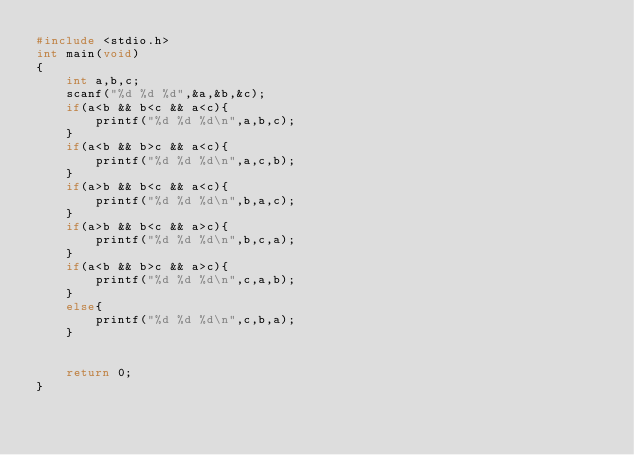<code> <loc_0><loc_0><loc_500><loc_500><_C_>#include <stdio.h>
int main(void)
{
	int a,b,c;
	scanf("%d %d %d",&a,&b,&c);
	if(a<b && b<c && a<c){
		printf("%d %d %d\n",a,b,c);
	}
	if(a<b && b>c && a<c){
		printf("%d %d %d\n",a,c,b);
	}
	if(a>b && b<c && a<c){
		printf("%d %d %d\n",b,a,c);
	}
	if(a>b && b<c && a>c){
		printf("%d %d %d\n",b,c,a);
	}
	if(a<b && b>c && a>c){
		printf("%d %d %d\n",c,a,b);
	}
	else{
		printf("%d %d %d\n",c,b,a);
	}


	return 0;
}
</code> 